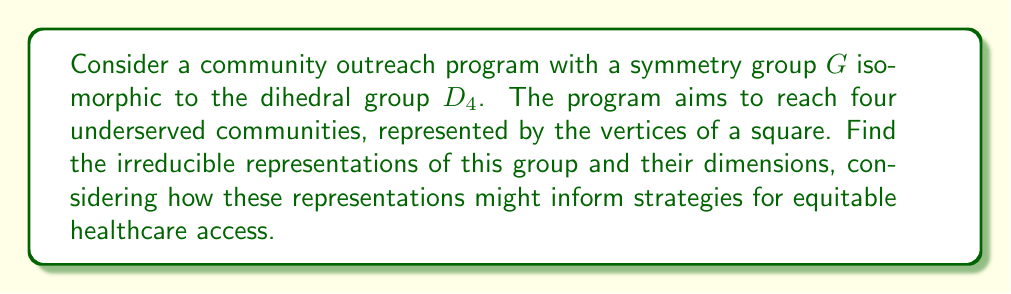Teach me how to tackle this problem. To find the irreducible representations of the group $G \cong D_4$, we'll follow these steps:

1) First, recall that $D_4$ has 8 elements: rotations by 0°, 90°, 180°, 270°, and four reflections.

2) The number of irreducible representations is equal to the number of conjugacy classes. For $D_4$, there are 5 conjugacy classes:
   - $\{e\}$ (identity)
   - $\{r^2\}$ (180° rotation)
   - $\{r, r^3\}$ (90° and 270° rotations)
   - $\{s, sr^2\}$ (reflections across diagonals)
   - $\{sr, sr^3\}$ (reflections across vertical and horizontal axes)

3) The sum of the squares of the dimensions of irreducible representations must equal the order of the group. So, if we denote the dimensions as $d_1, d_2, ..., d_5$, we have:

   $$d_1^2 + d_2^2 + d_3^2 + d_4^2 + d_5^2 = 8$$

4) $D_4$ has 4 one-dimensional representations:
   - The trivial representation
   - The sign representation (determinant)
   - Two more where rotations act trivially and reflections act as ±1

5) This leaves one two-dimensional representation to satisfy the equation in step 3.

6) The character table for $D_4$ is:

   $$\begin{array}{c|ccccc}
      & \{e\} & \{r^2\} & \{r, r^3\} & \{s, sr^2\} & \{sr, sr^3\} \\
   \hline
   \chi_1 & 1 & 1 & 1 & 1 & 1 \\
   \chi_2 & 1 & 1 & 1 & -1 & -1 \\
   \chi_3 & 1 & 1 & -1 & 1 & -1 \\
   \chi_4 & 1 & 1 & -1 & -1 & 1 \\
   \chi_5 & 2 & -2 & 0 & 0 & 0
   \end{array}$$

In the context of the community outreach program, these representations could be interpreted as follows:
- $\chi_1$: Uniform approach to all communities
- $\chi_2$: Distinguishing between diagonal and axial communities
- $\chi_3$: Distinguishing between rotated and reflected communities
- $\chi_4$: Combination of $\chi_2$ and $\chi_3$
- $\chi_5$: Complex strategies considering all symmetries
Answer: Four 1-dimensional representations and one 2-dimensional representation. 